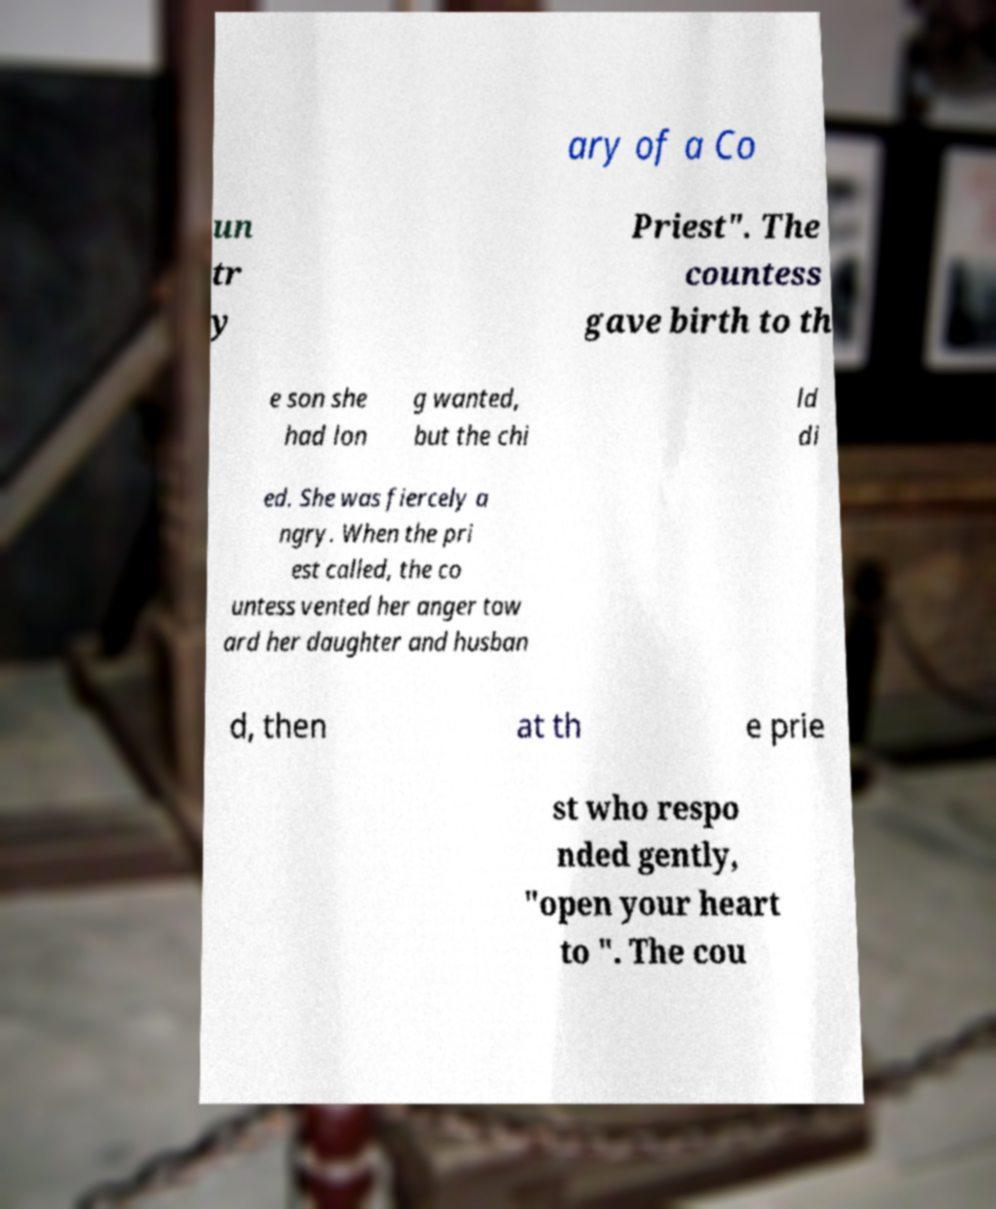For documentation purposes, I need the text within this image transcribed. Could you provide that? ary of a Co un tr y Priest". The countess gave birth to th e son she had lon g wanted, but the chi ld di ed. She was fiercely a ngry. When the pri est called, the co untess vented her anger tow ard her daughter and husban d, then at th e prie st who respo nded gently, "open your heart to ". The cou 